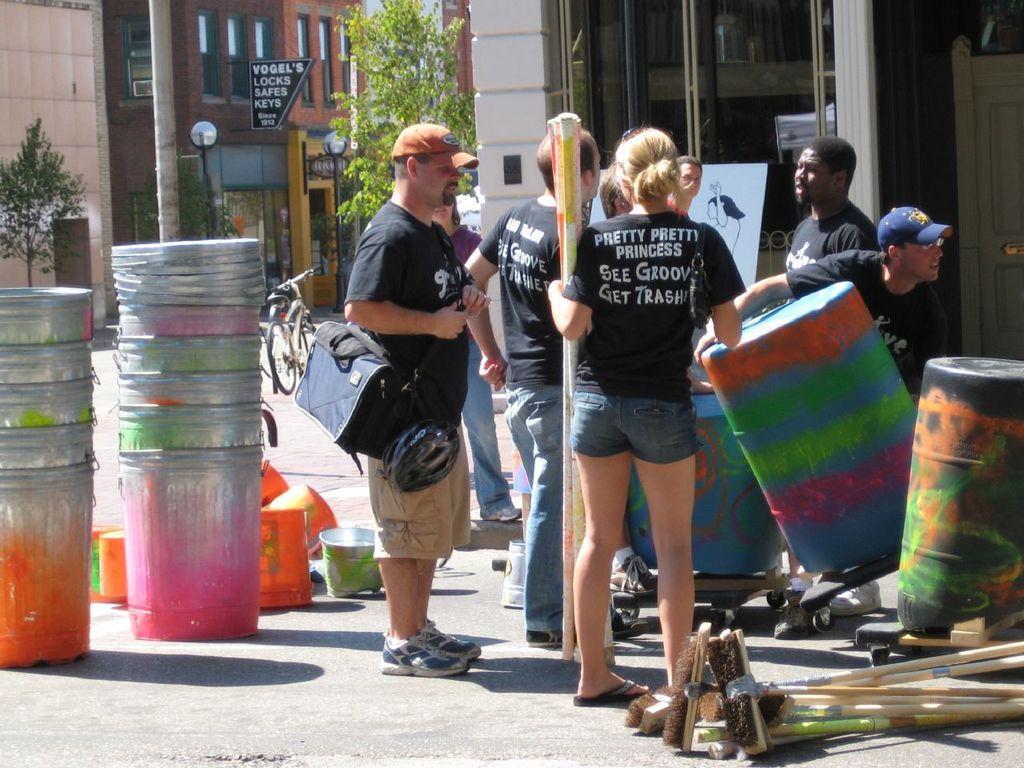Describe this image in one or two sentences. This picture is clicked outside. On the right we can see the group of persons wearing black t-shirts and standing on the ground and there is a person holding an object and we can see the sticks and some other objects are placed on the ground. In the background we can see the buildings, trees, lights attached to the poles and a board on which we can see the text is printed. 